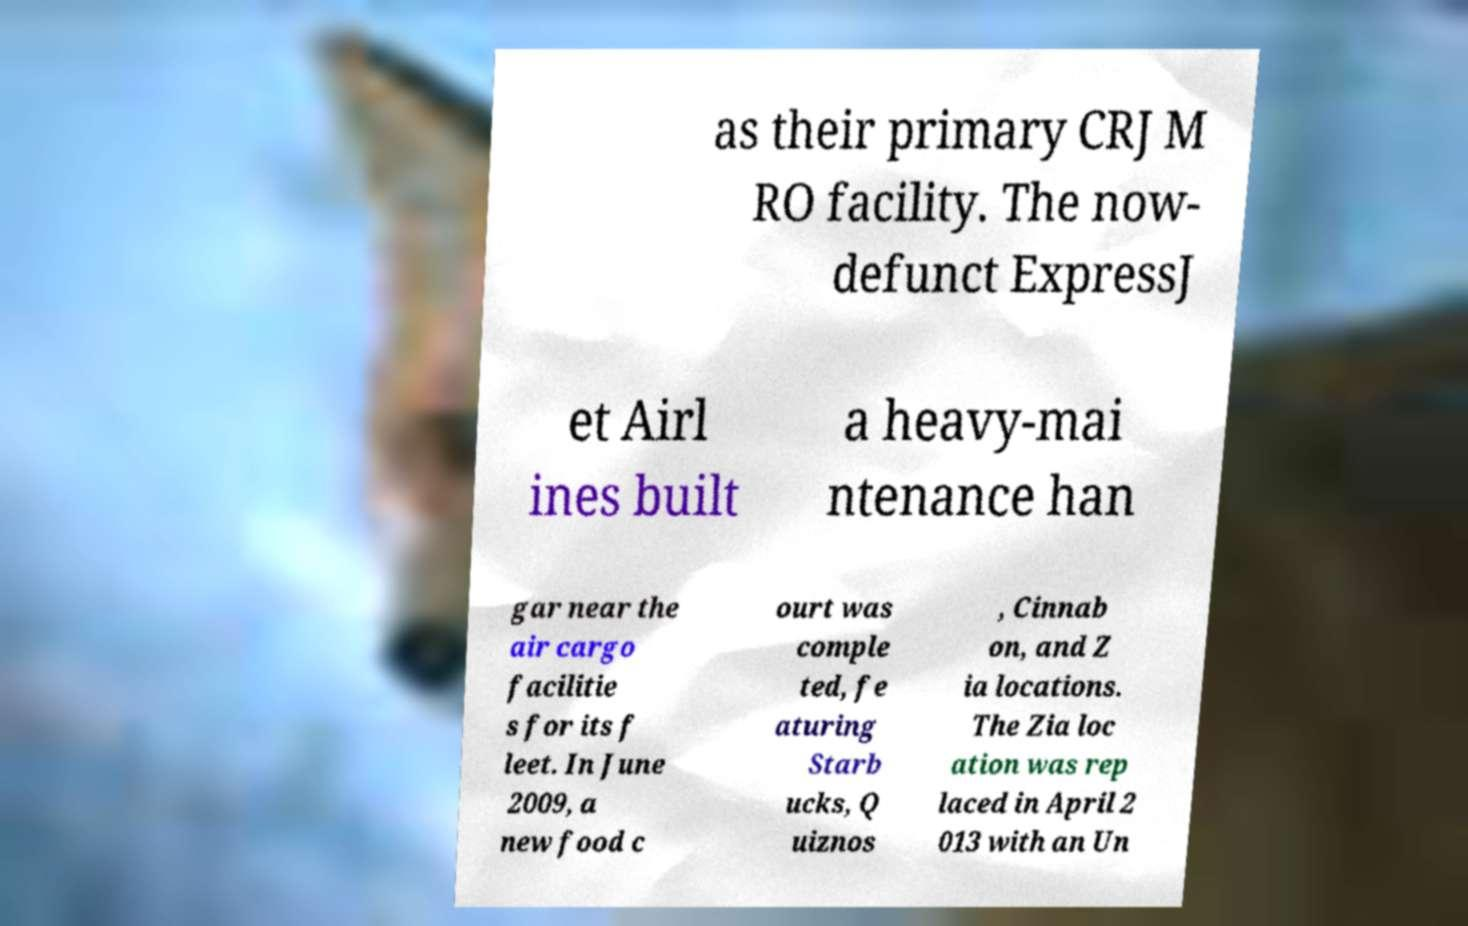What messages or text are displayed in this image? I need them in a readable, typed format. as their primary CRJ M RO facility. The now- defunct ExpressJ et Airl ines built a heavy-mai ntenance han gar near the air cargo facilitie s for its f leet. In June 2009, a new food c ourt was comple ted, fe aturing Starb ucks, Q uiznos , Cinnab on, and Z ia locations. The Zia loc ation was rep laced in April 2 013 with an Un 